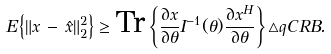<formula> <loc_0><loc_0><loc_500><loc_500>E \left \{ \| x \, - \, \hat { x } \| ^ { 2 } _ { 2 } \right \} \geq \text {Tr} \left \{ \frac { \partial x } { \partial \theta } I ^ { - 1 } ( \theta ) \frac { \partial x ^ { H } } { \partial \theta } \right \} \triangle q C R B .</formula> 